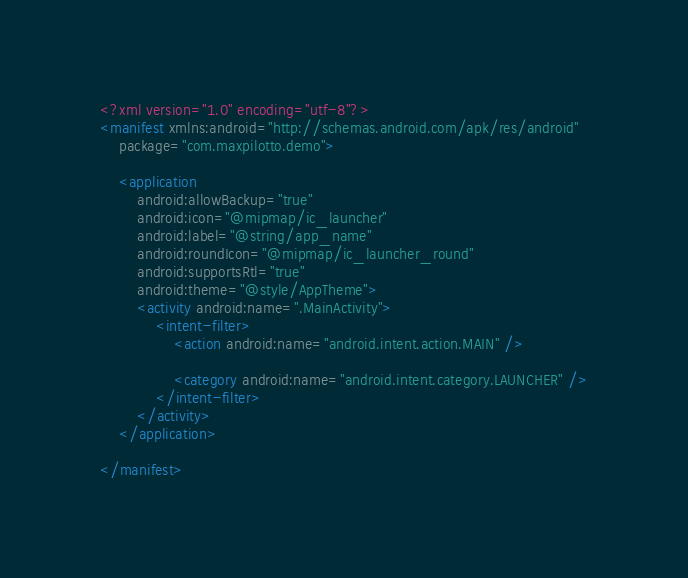<code> <loc_0><loc_0><loc_500><loc_500><_XML_><?xml version="1.0" encoding="utf-8"?>
<manifest xmlns:android="http://schemas.android.com/apk/res/android"
    package="com.maxpilotto.demo">

    <application
        android:allowBackup="true"
        android:icon="@mipmap/ic_launcher"
        android:label="@string/app_name"
        android:roundIcon="@mipmap/ic_launcher_round"
        android:supportsRtl="true"
        android:theme="@style/AppTheme">
        <activity android:name=".MainActivity">
            <intent-filter>
                <action android:name="android.intent.action.MAIN" />

                <category android:name="android.intent.category.LAUNCHER" />
            </intent-filter>
        </activity>
    </application>

</manifest></code> 